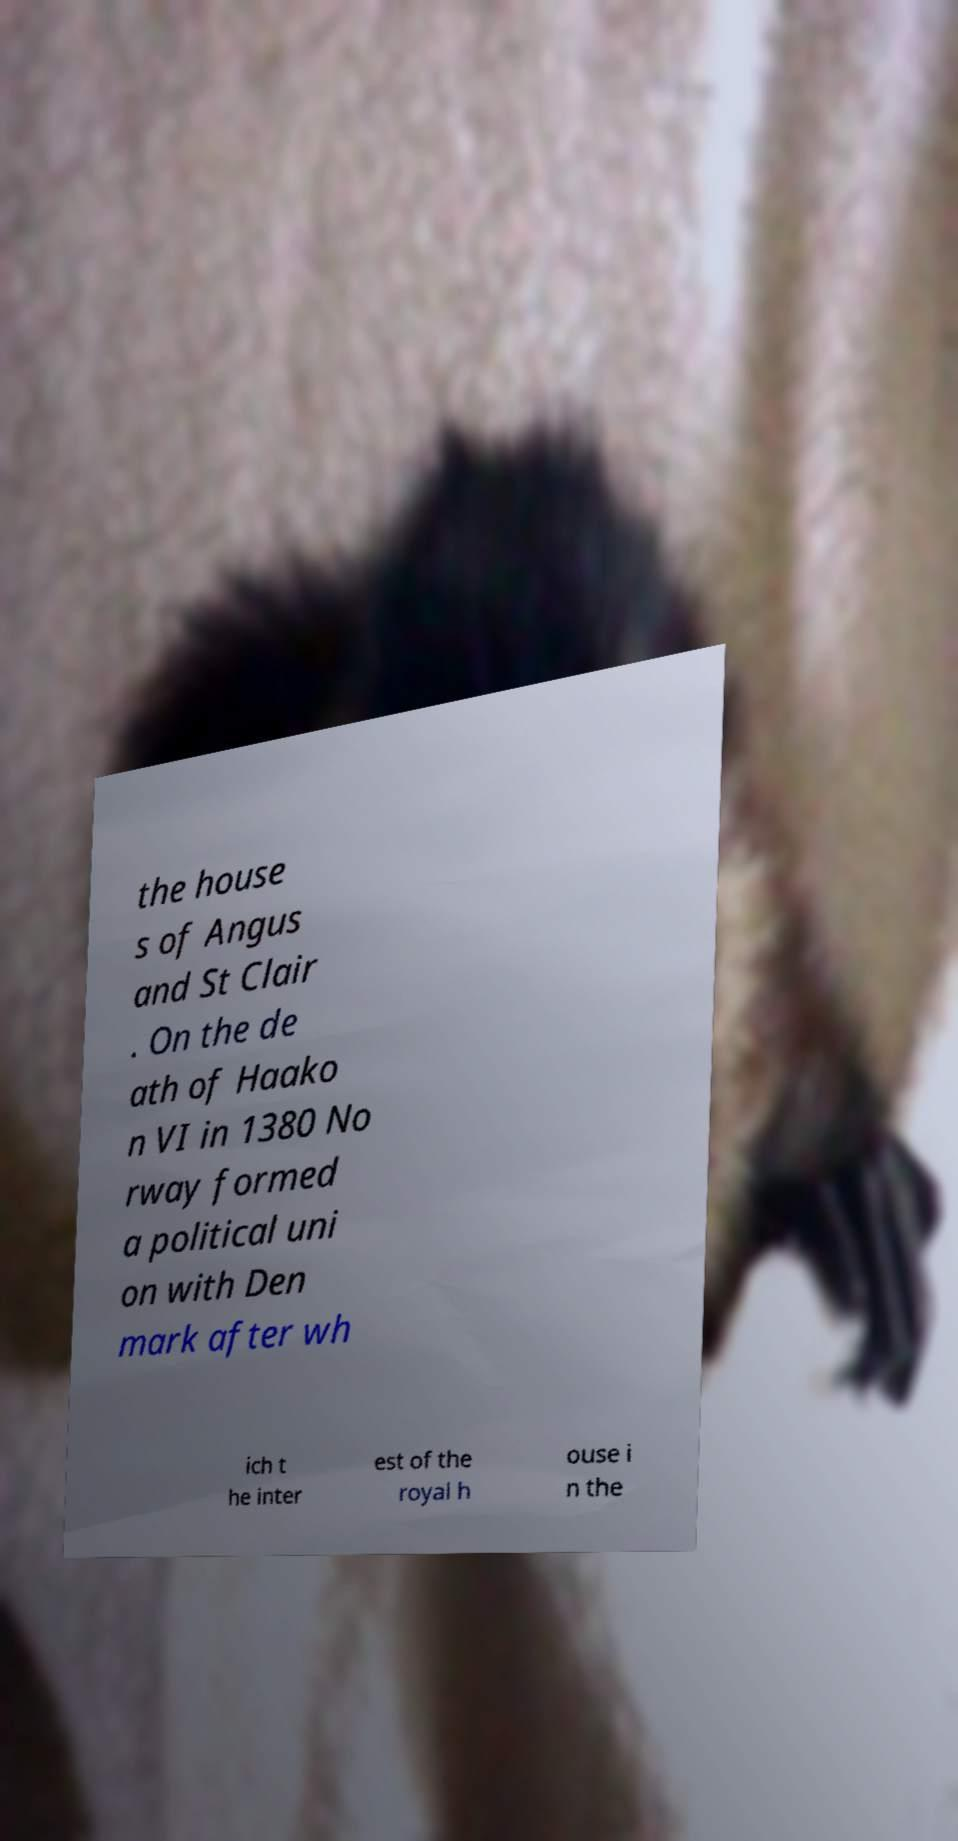Could you assist in decoding the text presented in this image and type it out clearly? the house s of Angus and St Clair . On the de ath of Haako n VI in 1380 No rway formed a political uni on with Den mark after wh ich t he inter est of the royal h ouse i n the 